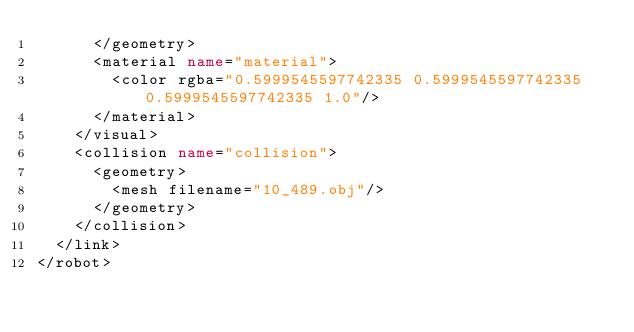Convert code to text. <code><loc_0><loc_0><loc_500><loc_500><_XML_>      </geometry>
      <material name="material">
        <color rgba="0.5999545597742335 0.5999545597742335 0.5999545597742335 1.0"/>
      </material>
    </visual>
    <collision name="collision">
      <geometry>
        <mesh filename="10_489.obj"/>
      </geometry>
    </collision>
  </link>
</robot>
</code> 